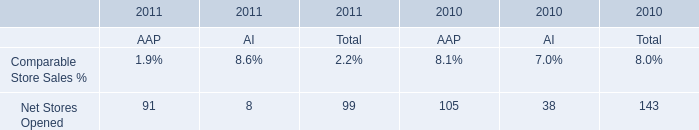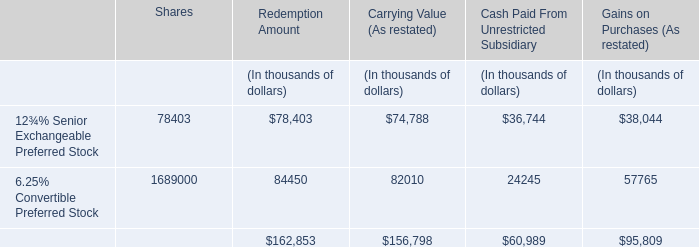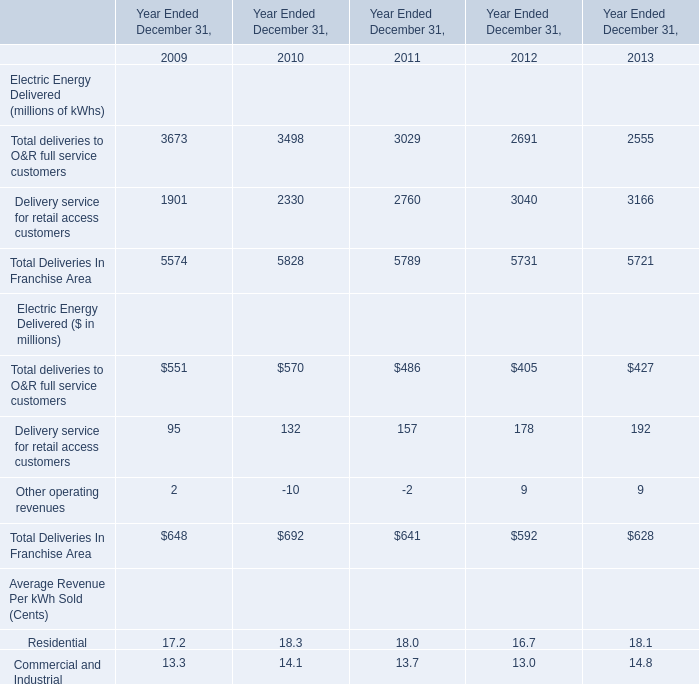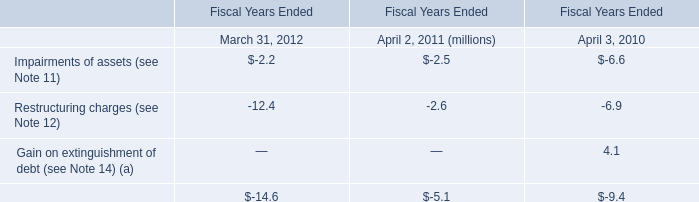In which year the Total deliveries to O&R full service customers of Electric Energy Delivered (millions of kWhs) is positive? 
Answer: 2009. 